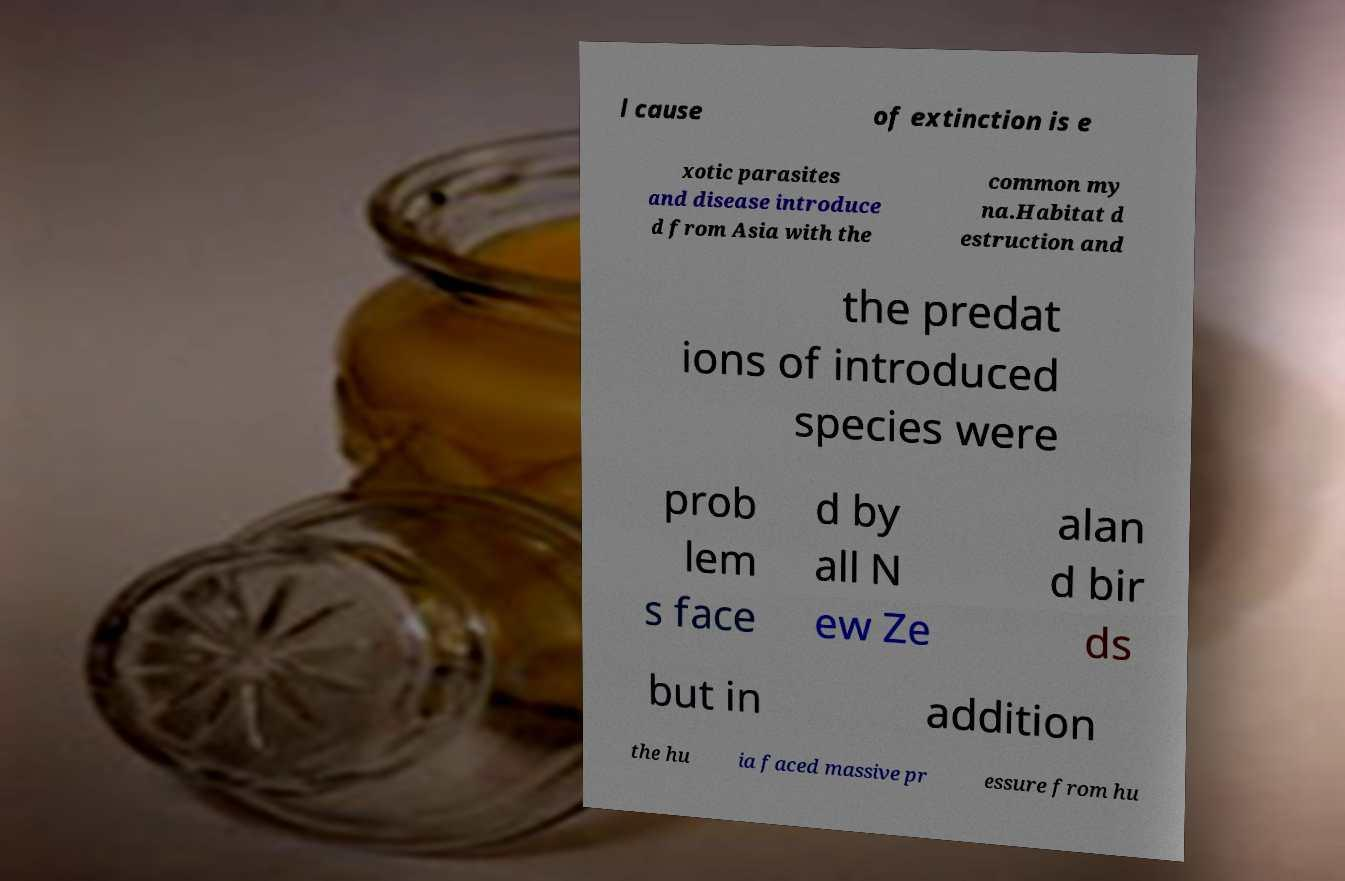What messages or text are displayed in this image? I need them in a readable, typed format. l cause of extinction is e xotic parasites and disease introduce d from Asia with the common my na.Habitat d estruction and the predat ions of introduced species were prob lem s face d by all N ew Ze alan d bir ds but in addition the hu ia faced massive pr essure from hu 